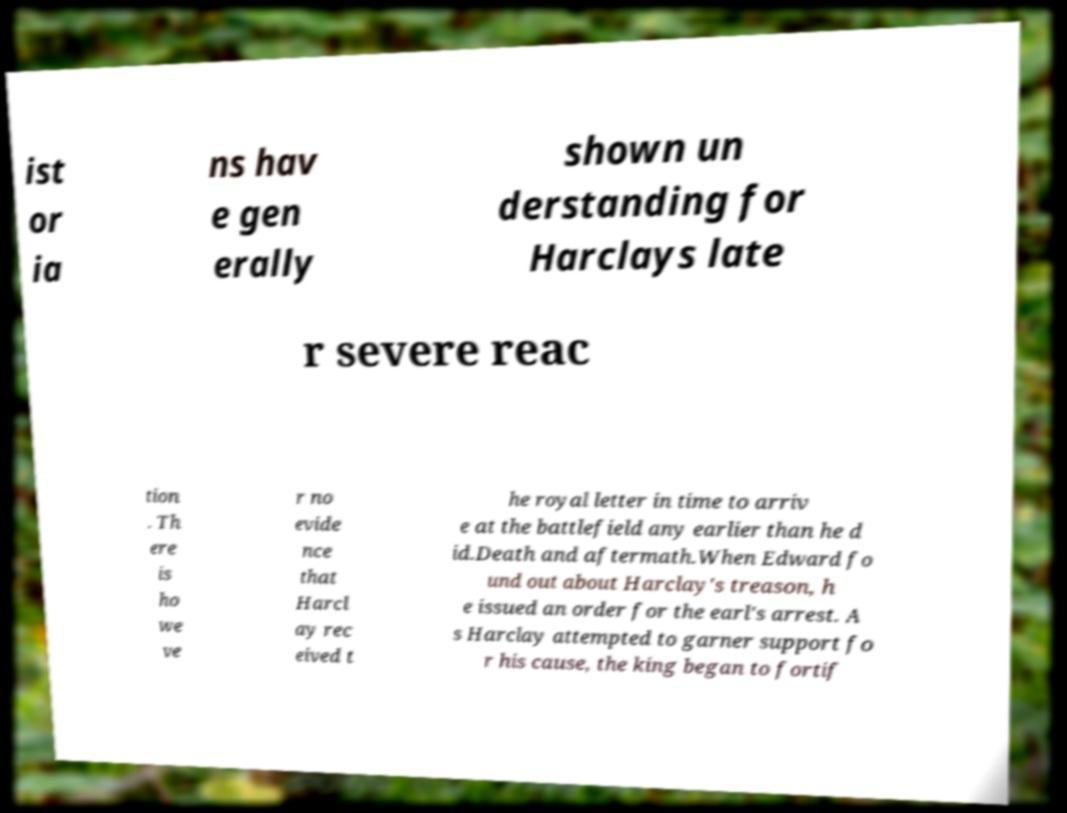Could you extract and type out the text from this image? ist or ia ns hav e gen erally shown un derstanding for Harclays late r severe reac tion . Th ere is ho we ve r no evide nce that Harcl ay rec eived t he royal letter in time to arriv e at the battlefield any earlier than he d id.Death and aftermath.When Edward fo und out about Harclay's treason, h e issued an order for the earl's arrest. A s Harclay attempted to garner support fo r his cause, the king began to fortif 